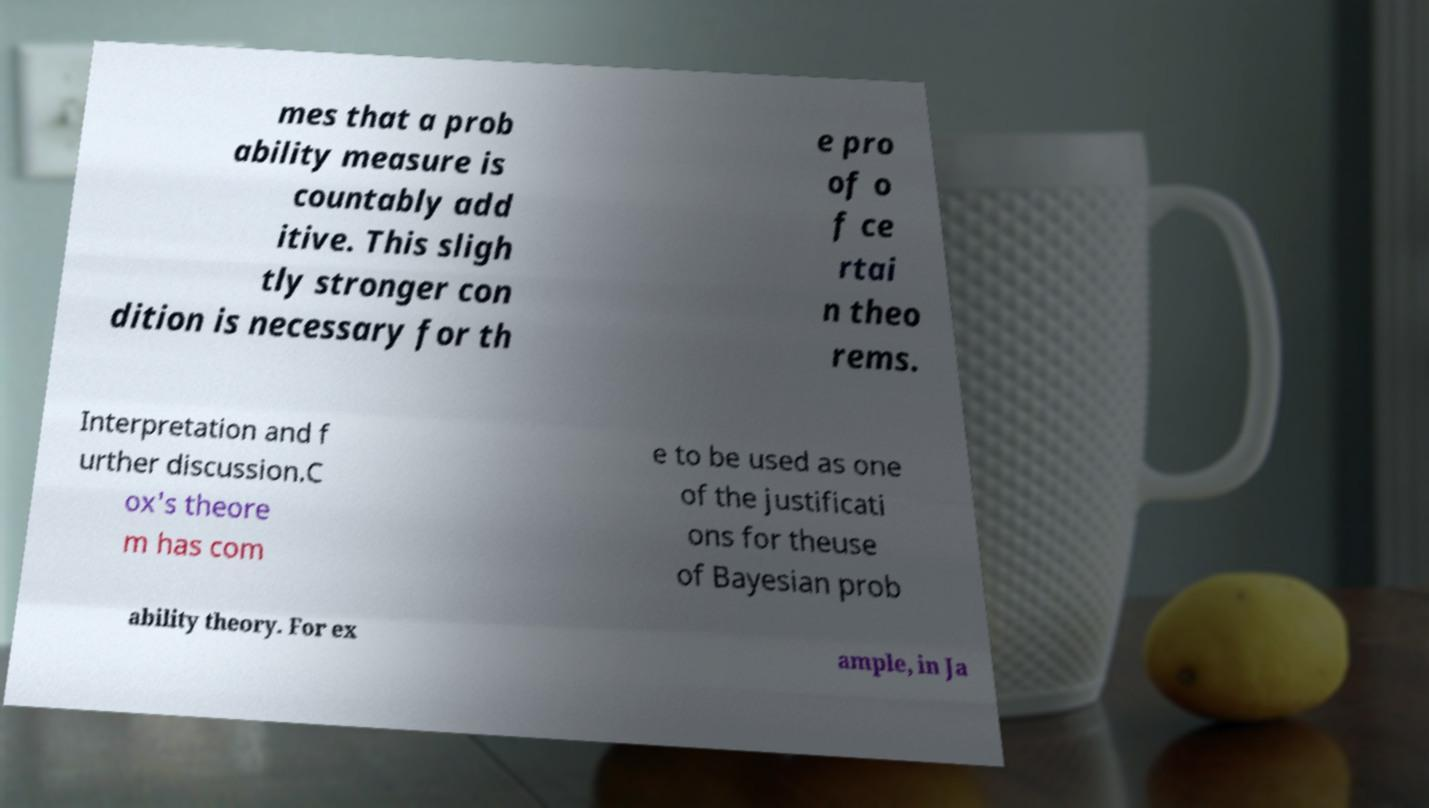Please read and relay the text visible in this image. What does it say? mes that a prob ability measure is countably add itive. This sligh tly stronger con dition is necessary for th e pro of o f ce rtai n theo rems. Interpretation and f urther discussion.C ox's theore m has com e to be used as one of the justificati ons for theuse of Bayesian prob ability theory. For ex ample, in Ja 